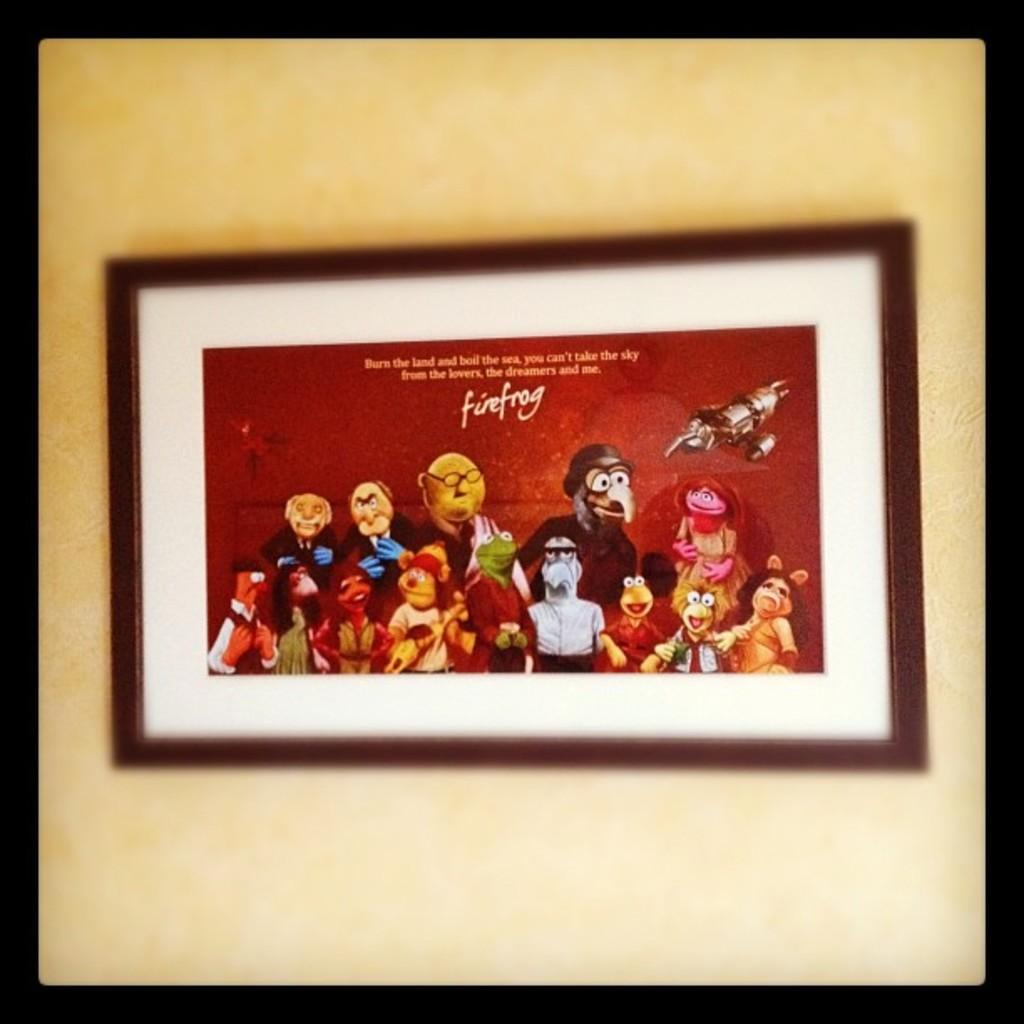What is hanging on the wall in the image? There is a photo frame on the wall. What type of pictures are inside the photo frame? The photo frame contains cartoon pictures. Is there any text associated with the photo frame? Yes, there is text on the top of the photo. What type of trousers are the cartoon characters wearing in the image? There are no cartoon characters visible in the image, only cartoon pictures within the photo frame. Is there a bone present in the image? There is no bone present in the image. 